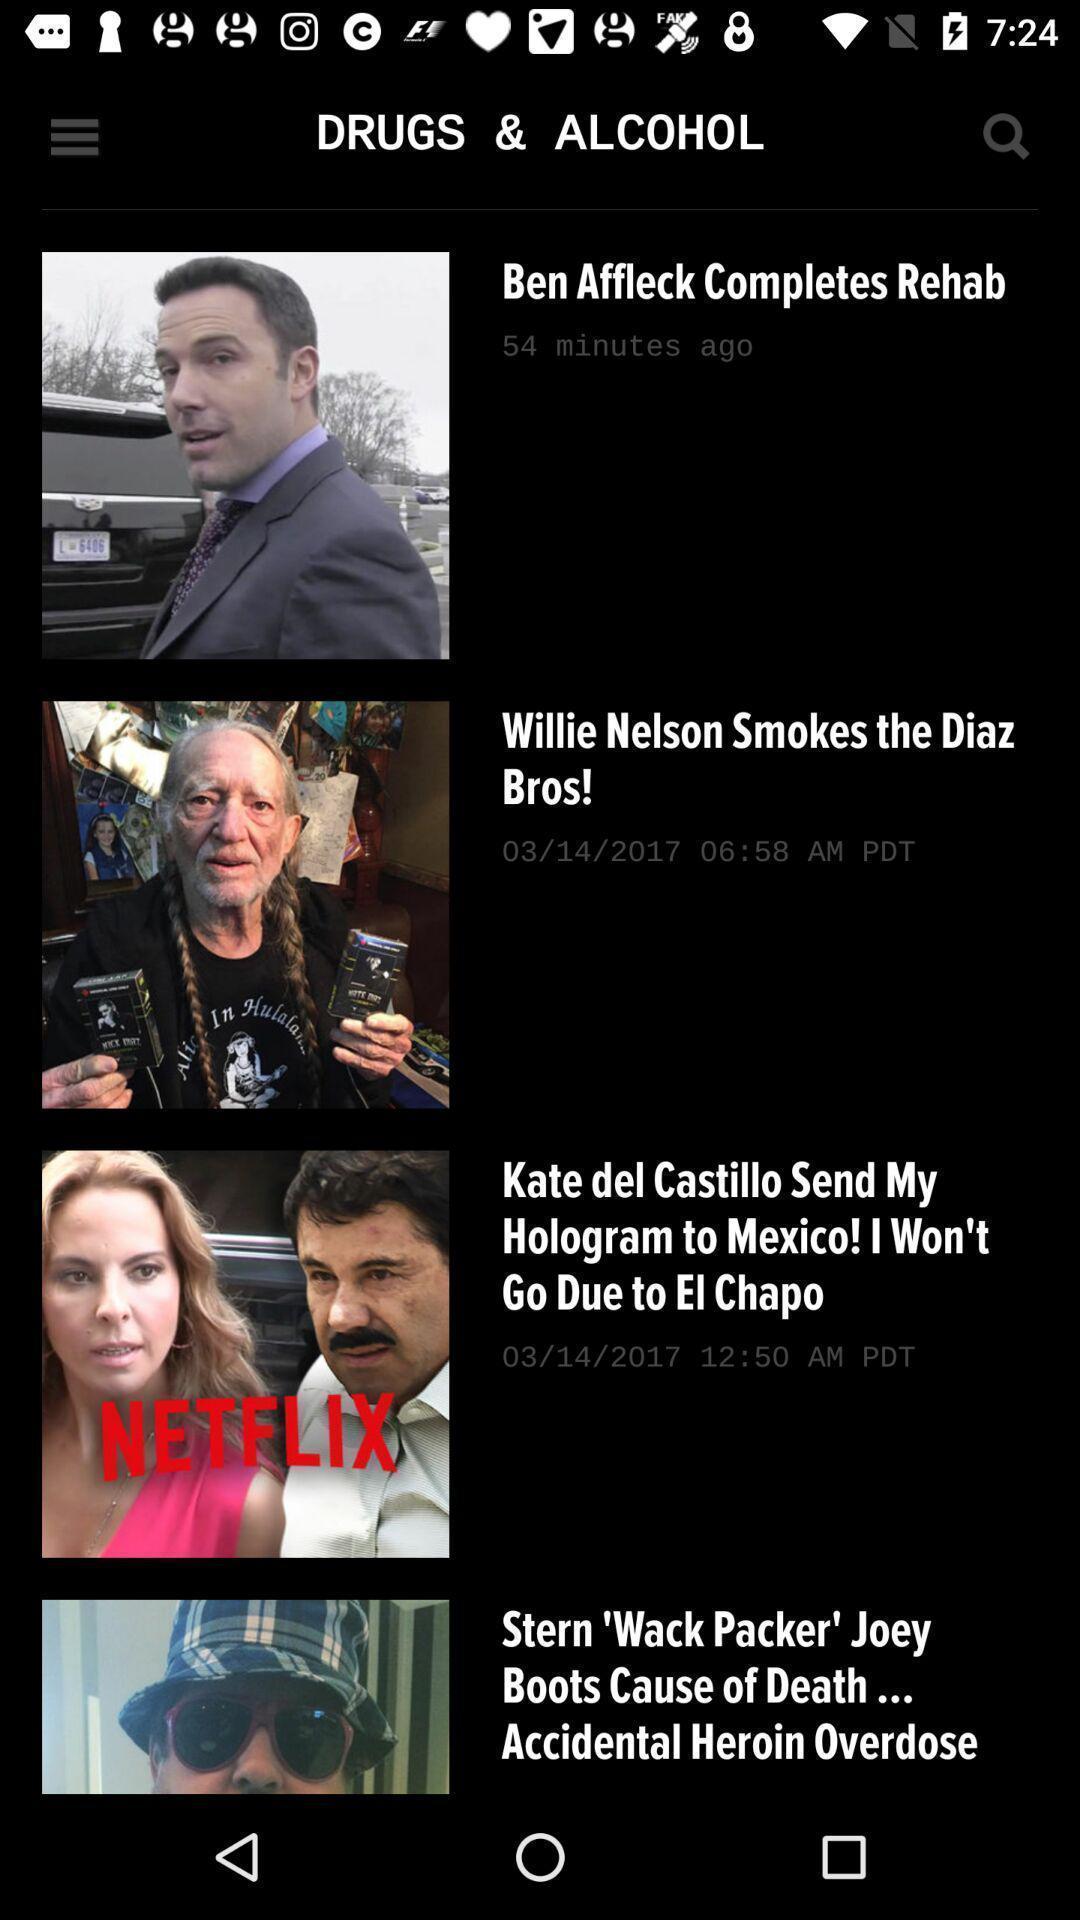Tell me about the visual elements in this screen capture. Screen shows multiple articles in news app. 